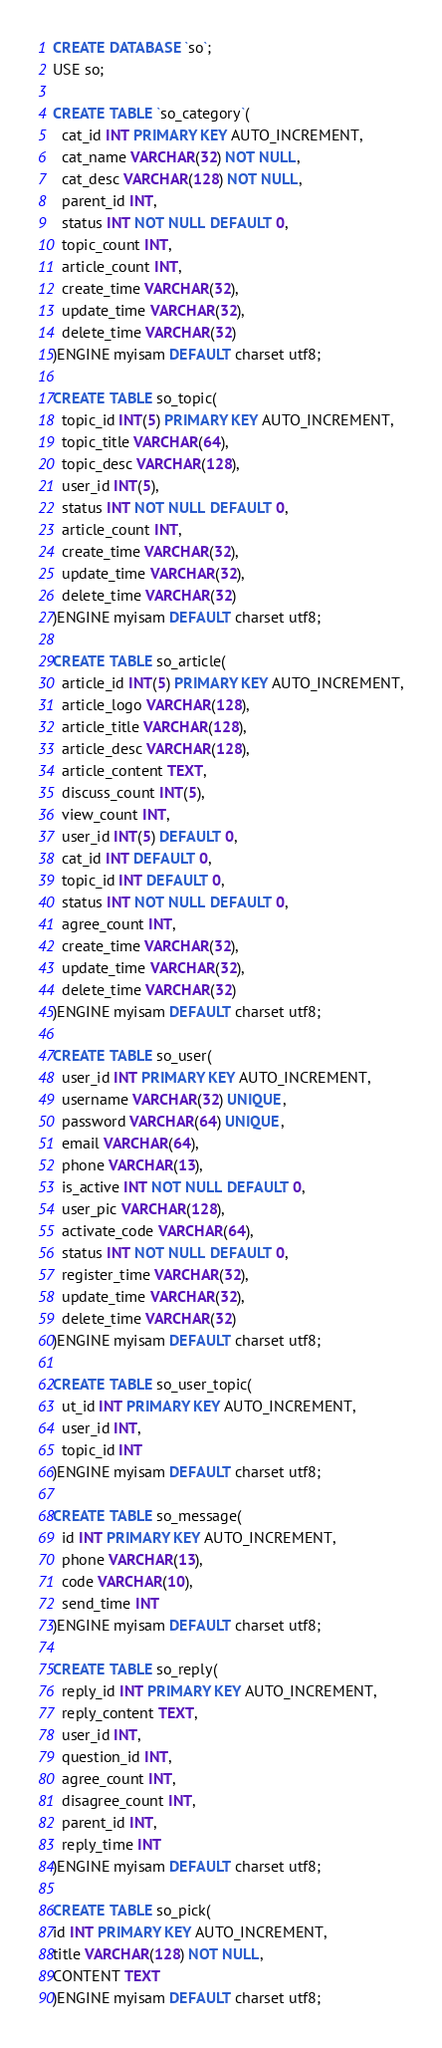<code> <loc_0><loc_0><loc_500><loc_500><_SQL_>CREATE DATABASE `so`;
USE so;

CREATE TABLE `so_category`(
  cat_id INT PRIMARY KEY AUTO_INCREMENT,
  cat_name VARCHAR(32) NOT NULL,
  cat_desc VARCHAR(128) NOT NULL,
  parent_id INT,
  status INT NOT NULL DEFAULT 0,
  topic_count INT,
  article_count INT,
  create_time VARCHAR(32),
  update_time VARCHAR(32),
  delete_time VARCHAR(32)
)ENGINE myisam DEFAULT charset utf8;

CREATE TABLE so_topic(
  topic_id INT(5) PRIMARY KEY AUTO_INCREMENT,
  topic_title VARCHAR(64),
  topic_desc VARCHAR(128),
  user_id INT(5),
  status INT NOT NULL DEFAULT 0,
  article_count INT,
  create_time VARCHAR(32),
  update_time VARCHAR(32),
  delete_time VARCHAR(32)
)ENGINE myisam DEFAULT charset utf8;

CREATE TABLE so_article(
  article_id INT(5) PRIMARY KEY AUTO_INCREMENT,
  article_logo VARCHAR(128),
  article_title VARCHAR(128),
  article_desc VARCHAR(128),
  article_content TEXT,
  discuss_count INT(5),
  view_count INT,
  user_id INT(5) DEFAULT 0,
  cat_id INT DEFAULT 0,
  topic_id INT DEFAULT 0,
  status INT NOT NULL DEFAULT 0,
  agree_count INT,
  create_time VARCHAR(32),
  update_time VARCHAR(32),
  delete_time VARCHAR(32)
)ENGINE myisam DEFAULT charset utf8;

CREATE TABLE so_user(
  user_id INT PRIMARY KEY AUTO_INCREMENT,
  username VARCHAR(32) UNIQUE,
  password VARCHAR(64) UNIQUE,
  email VARCHAR(64),
  phone VARCHAR(13),
  is_active INT NOT NULL DEFAULT 0,
  user_pic VARCHAR(128),
  activate_code VARCHAR(64),
  status INT NOT NULL DEFAULT 0,
  register_time VARCHAR(32),
  update_time VARCHAR(32),
  delete_time VARCHAR(32)
)ENGINE myisam DEFAULT charset utf8;

CREATE TABLE so_user_topic(
  ut_id INT PRIMARY KEY AUTO_INCREMENT,
  user_id INT,
  topic_id INT
)ENGINE myisam DEFAULT charset utf8;

CREATE TABLE so_message(
  id INT PRIMARY KEY AUTO_INCREMENT,
  phone VARCHAR(13),
  code VARCHAR(10),
  send_time INT
)ENGINE myisam DEFAULT charset utf8;

CREATE TABLE so_reply(
  reply_id INT PRIMARY KEY AUTO_INCREMENT,
  reply_content TEXT,
  user_id INT,
  question_id INT,
  agree_count INT,
  disagree_count INT,
  parent_id INT,
  reply_time INT
)ENGINE myisam DEFAULT charset utf8;

CREATE TABLE so_pick(
id INT PRIMARY KEY AUTO_INCREMENT,
title VARCHAR(128) NOT NULL,
CONTENT TEXT
)ENGINE myisam DEFAULT charset utf8;
</code> 